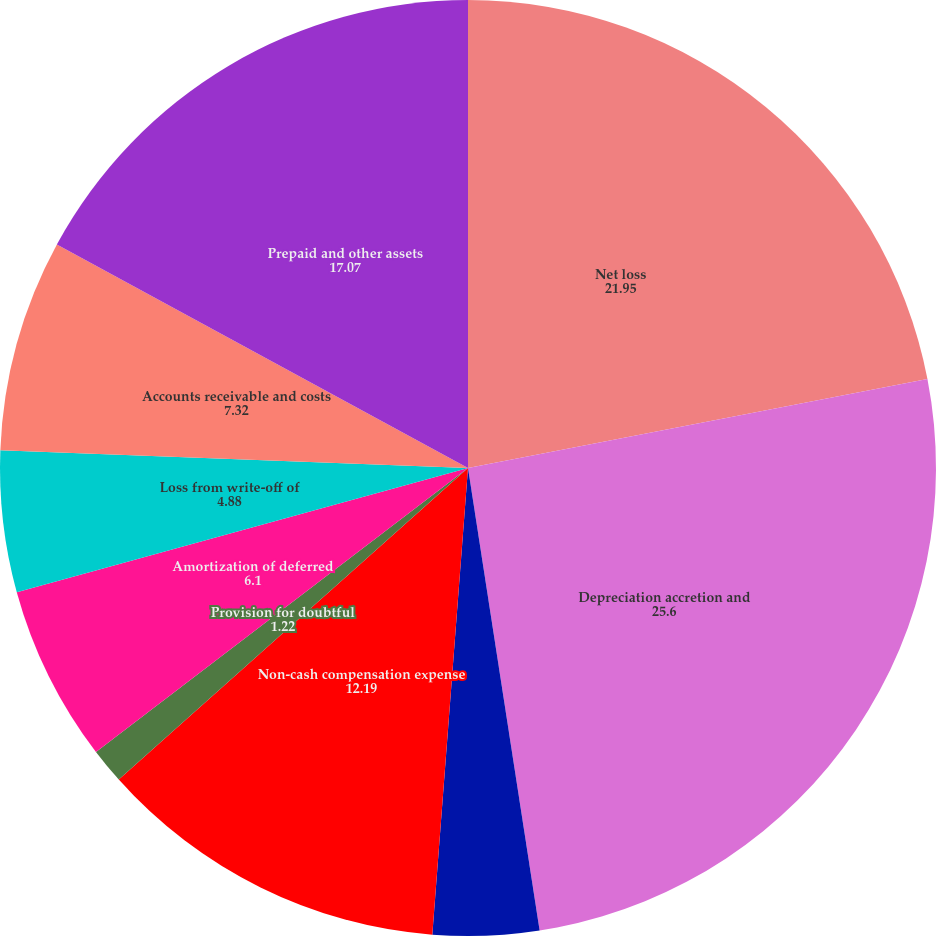<chart> <loc_0><loc_0><loc_500><loc_500><pie_chart><fcel>Net loss<fcel>Depreciation accretion and<fcel>Loss (gain) on sale of assets<fcel>Non-cash compensation expense<fcel>Provision for doubtful<fcel>Amortization of deferred<fcel>Loss from write-off of<fcel>Accounts receivable and costs<fcel>Prepaid and other assets<nl><fcel>21.95%<fcel>25.6%<fcel>3.66%<fcel>12.19%<fcel>1.22%<fcel>6.1%<fcel>4.88%<fcel>7.32%<fcel>17.07%<nl></chart> 